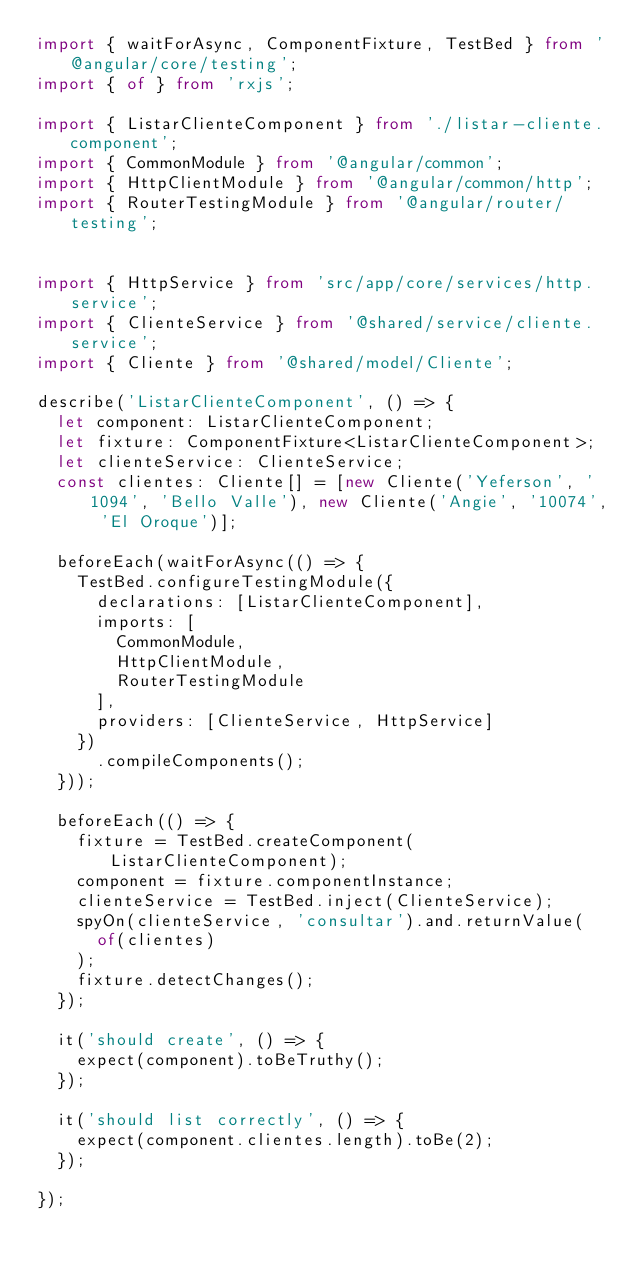Convert code to text. <code><loc_0><loc_0><loc_500><loc_500><_TypeScript_>import { waitForAsync, ComponentFixture, TestBed } from '@angular/core/testing';
import { of } from 'rxjs';

import { ListarClienteComponent } from './listar-cliente.component';
import { CommonModule } from '@angular/common';
import { HttpClientModule } from '@angular/common/http';
import { RouterTestingModule } from '@angular/router/testing';


import { HttpService } from 'src/app/core/services/http.service';
import { ClienteService } from '@shared/service/cliente.service';
import { Cliente } from '@shared/model/Cliente';

describe('ListarClienteComponent', () => {
  let component: ListarClienteComponent;
  let fixture: ComponentFixture<ListarClienteComponent>;
  let clienteService: ClienteService;
  const clientes: Cliente[] = [new Cliente('Yeferson', '1094', 'Bello Valle'), new Cliente('Angie', '10074', 'El Oroque')];

  beforeEach(waitForAsync(() => {
    TestBed.configureTestingModule({
      declarations: [ListarClienteComponent],
      imports: [
        CommonModule,
        HttpClientModule,
        RouterTestingModule
      ],
      providers: [ClienteService, HttpService]
    })
      .compileComponents();
  }));

  beforeEach(() => {
    fixture = TestBed.createComponent(ListarClienteComponent);
    component = fixture.componentInstance;
    clienteService = TestBed.inject(ClienteService);
    spyOn(clienteService, 'consultar').and.returnValue(
      of(clientes)
    );
    fixture.detectChanges();
  });

  it('should create', () => {
    expect(component).toBeTruthy();
  });

  it('should list correctly', () => {
    expect(component.clientes.length).toBe(2);
  });

});
</code> 